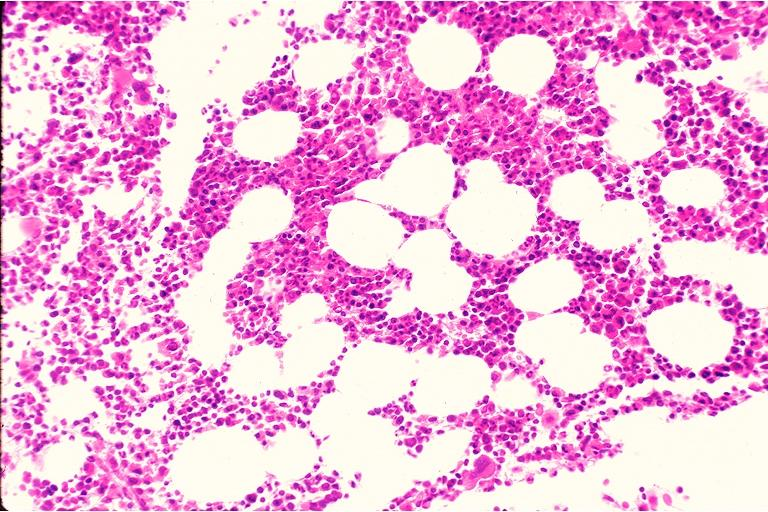s oral present?
Answer the question using a single word or phrase. Yes 